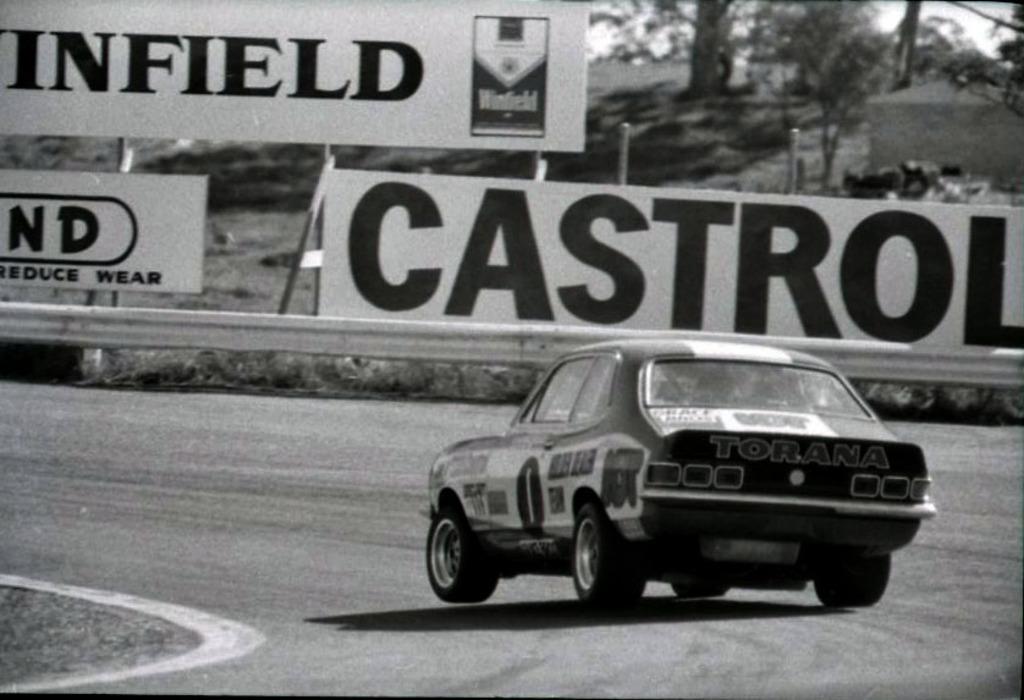How would you summarize this image in a sentence or two? This is a black and white image. Here I can see a car on the road. In the background there are some boards on which I can see some text. At the top there are some trees. 